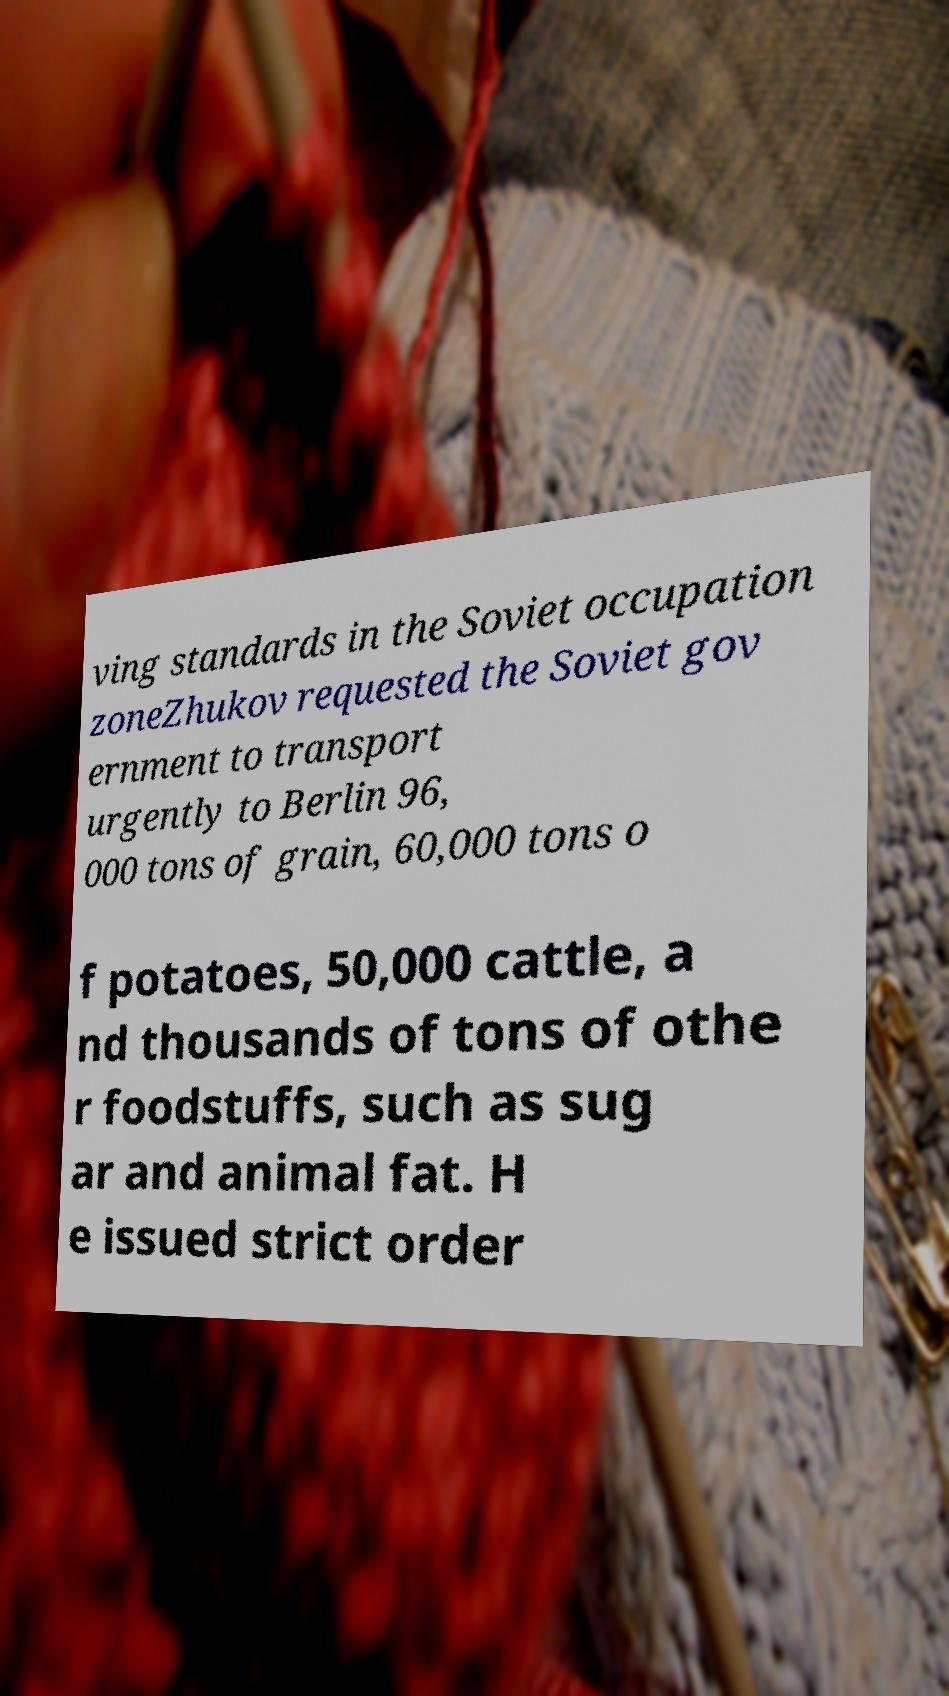Please read and relay the text visible in this image. What does it say? ving standards in the Soviet occupation zoneZhukov requested the Soviet gov ernment to transport urgently to Berlin 96, 000 tons of grain, 60,000 tons o f potatoes, 50,000 cattle, a nd thousands of tons of othe r foodstuffs, such as sug ar and animal fat. H e issued strict order 